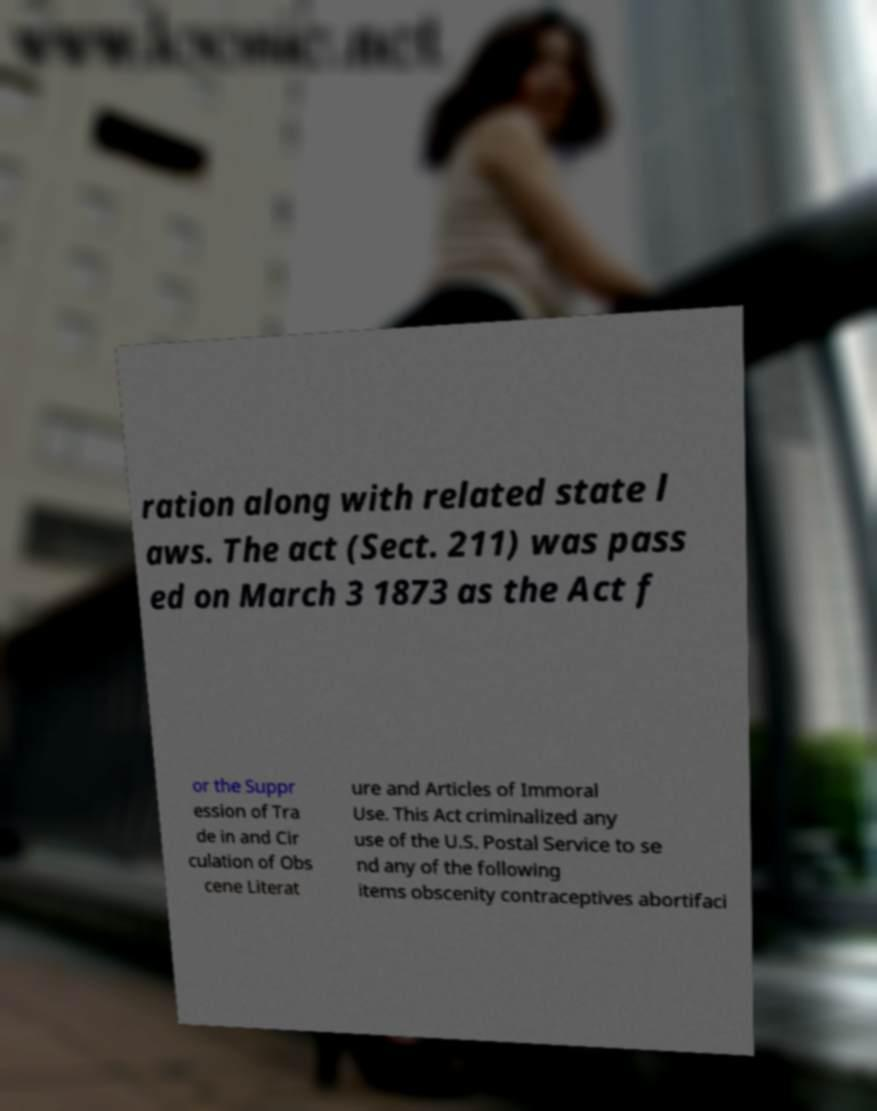Can you read and provide the text displayed in the image?This photo seems to have some interesting text. Can you extract and type it out for me? ration along with related state l aws. The act (Sect. 211) was pass ed on March 3 1873 as the Act f or the Suppr ession of Tra de in and Cir culation of Obs cene Literat ure and Articles of Immoral Use. This Act criminalized any use of the U.S. Postal Service to se nd any of the following items obscenity contraceptives abortifaci 